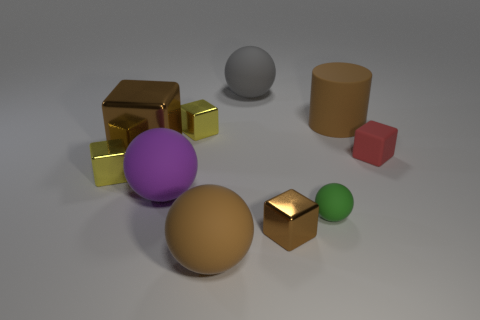Subtract 2 cubes. How many cubes are left? 3 Subtract all red cubes. How many cubes are left? 4 Subtract all purple spheres. How many spheres are left? 3 Subtract all blue blocks. Subtract all yellow cylinders. How many blocks are left? 5 Subtract all spheres. How many objects are left? 6 Subtract all tiny green things. Subtract all purple things. How many objects are left? 8 Add 8 small green balls. How many small green balls are left? 9 Add 4 tiny green spheres. How many tiny green spheres exist? 5 Subtract 0 gray blocks. How many objects are left? 10 